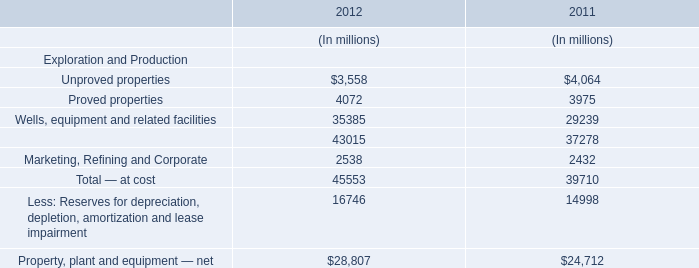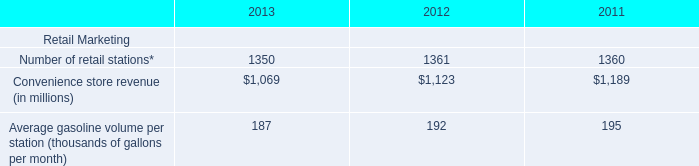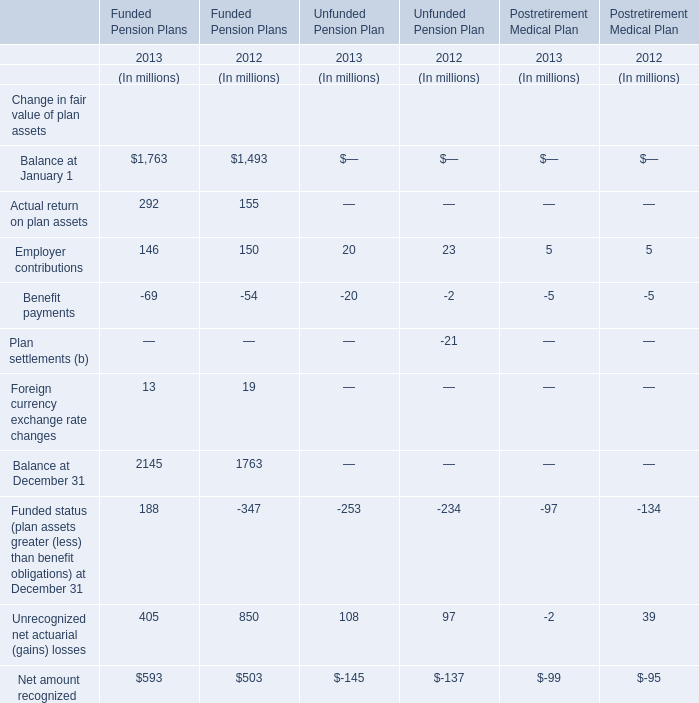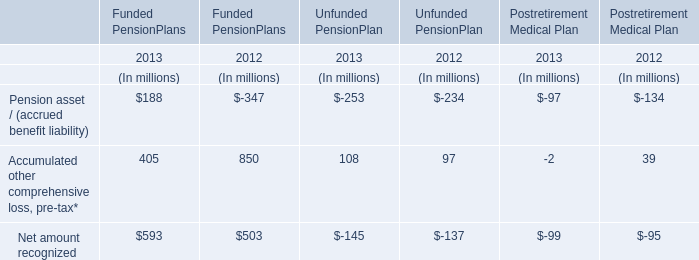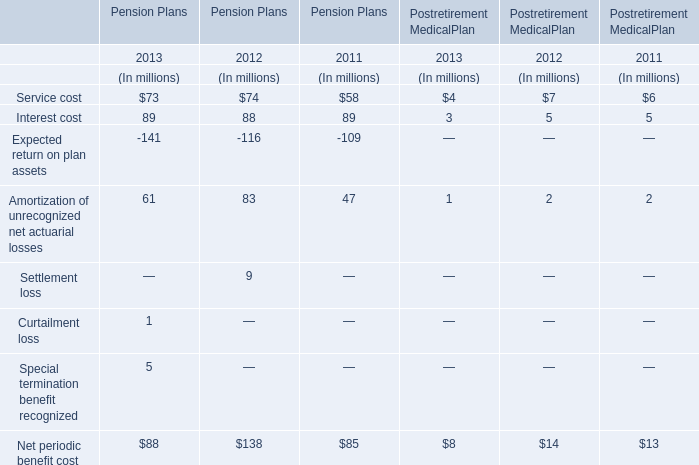Which section is Pension asset / (accrued benefit liability) the lowest? 
Answer: Unfunded PensionPlan. 